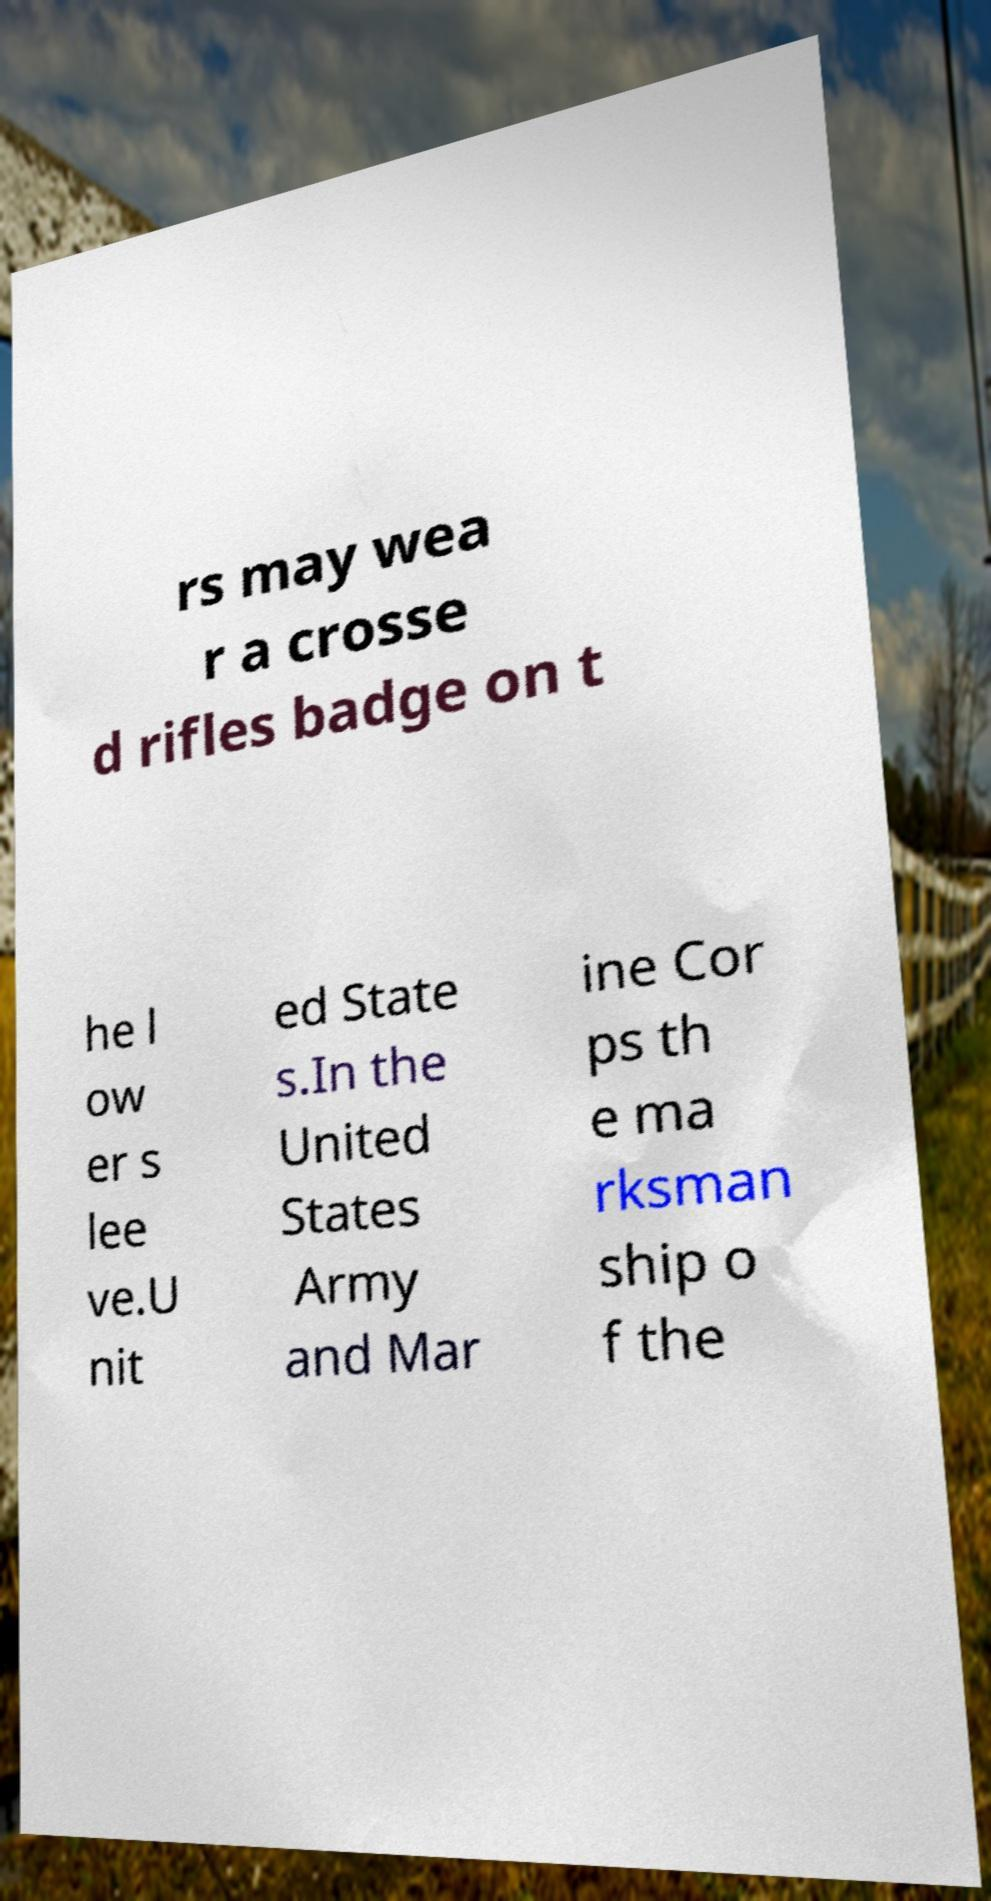Could you assist in decoding the text presented in this image and type it out clearly? rs may wea r a crosse d rifles badge on t he l ow er s lee ve.U nit ed State s.In the United States Army and Mar ine Cor ps th e ma rksman ship o f the 